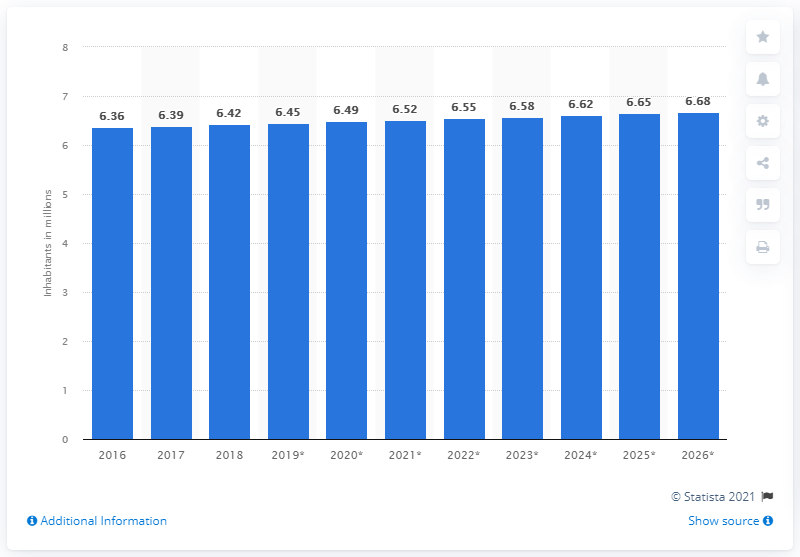Identify some key points in this picture. In 2018, the population of El Salvador was approximately 6.45 million people. 